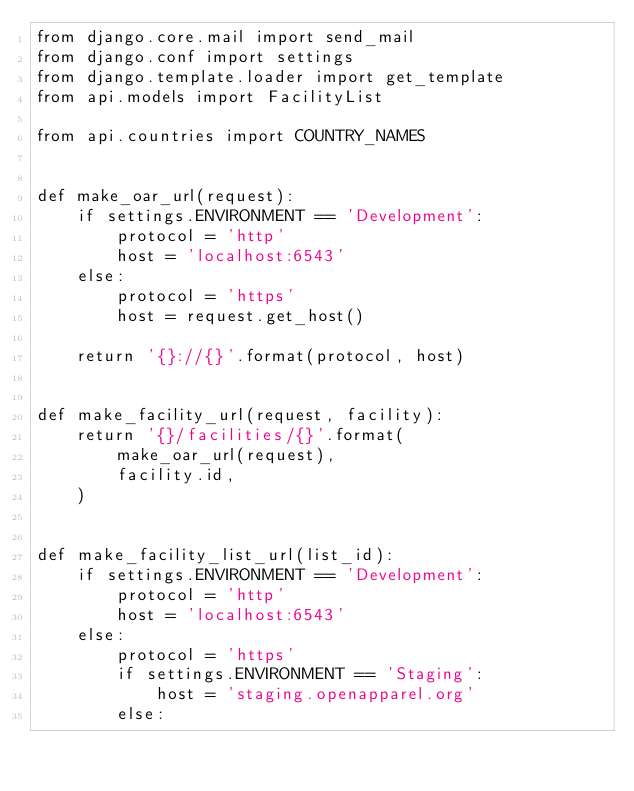Convert code to text. <code><loc_0><loc_0><loc_500><loc_500><_Python_>from django.core.mail import send_mail
from django.conf import settings
from django.template.loader import get_template
from api.models import FacilityList

from api.countries import COUNTRY_NAMES


def make_oar_url(request):
    if settings.ENVIRONMENT == 'Development':
        protocol = 'http'
        host = 'localhost:6543'
    else:
        protocol = 'https'
        host = request.get_host()

    return '{}://{}'.format(protocol, host)


def make_facility_url(request, facility):
    return '{}/facilities/{}'.format(
        make_oar_url(request),
        facility.id,
    )


def make_facility_list_url(list_id):
    if settings.ENVIRONMENT == 'Development':
        protocol = 'http'
        host = 'localhost:6543'
    else:
        protocol = 'https'
        if settings.ENVIRONMENT == 'Staging':
            host = 'staging.openapparel.org'
        else:</code> 